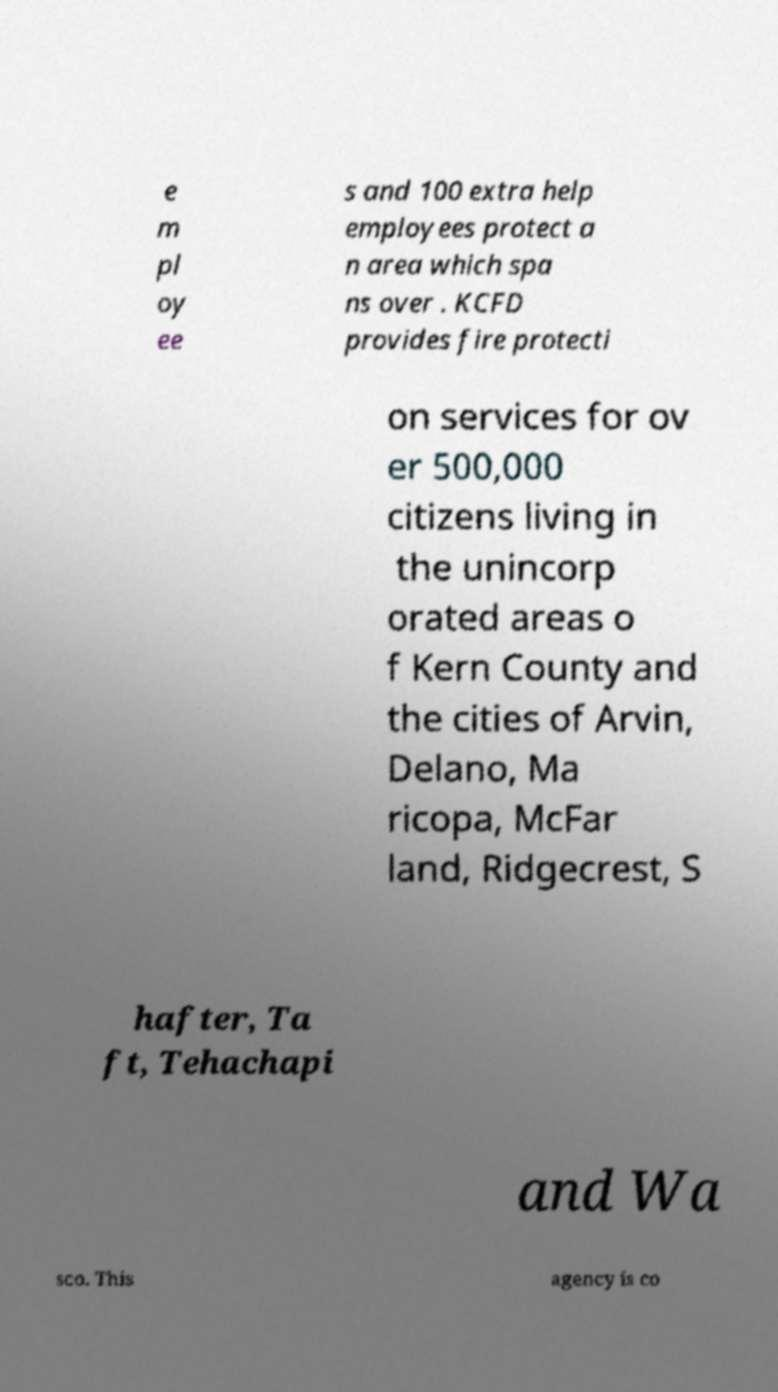There's text embedded in this image that I need extracted. Can you transcribe it verbatim? e m pl oy ee s and 100 extra help employees protect a n area which spa ns over . KCFD provides fire protecti on services for ov er 500,000 citizens living in the unincorp orated areas o f Kern County and the cities of Arvin, Delano, Ma ricopa, McFar land, Ridgecrest, S hafter, Ta ft, Tehachapi and Wa sco. This agency is co 